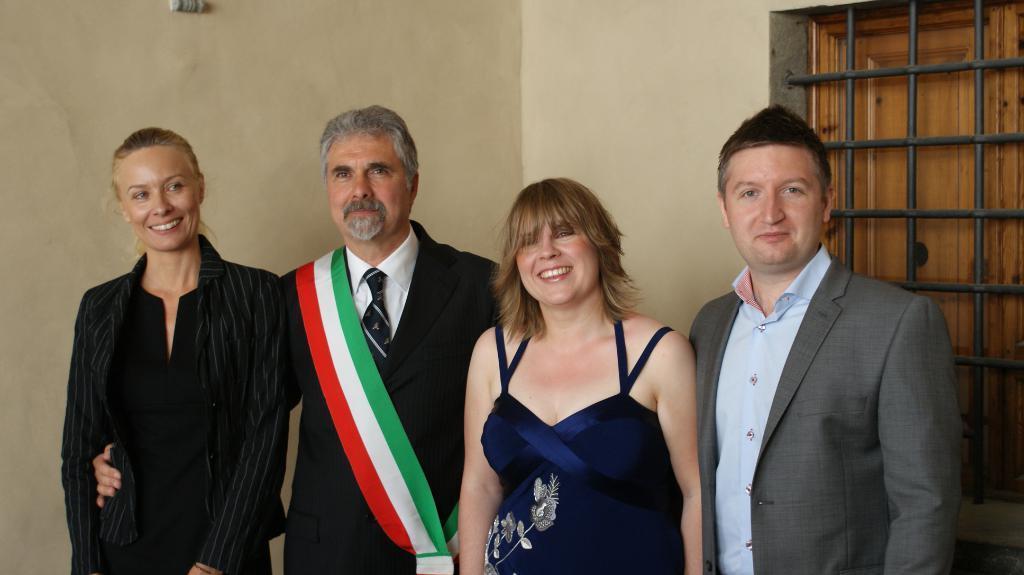Describe this image in one or two sentences. In this image I can see a group of people. On the right side, I can see a window. In the background, I can see the wall. 